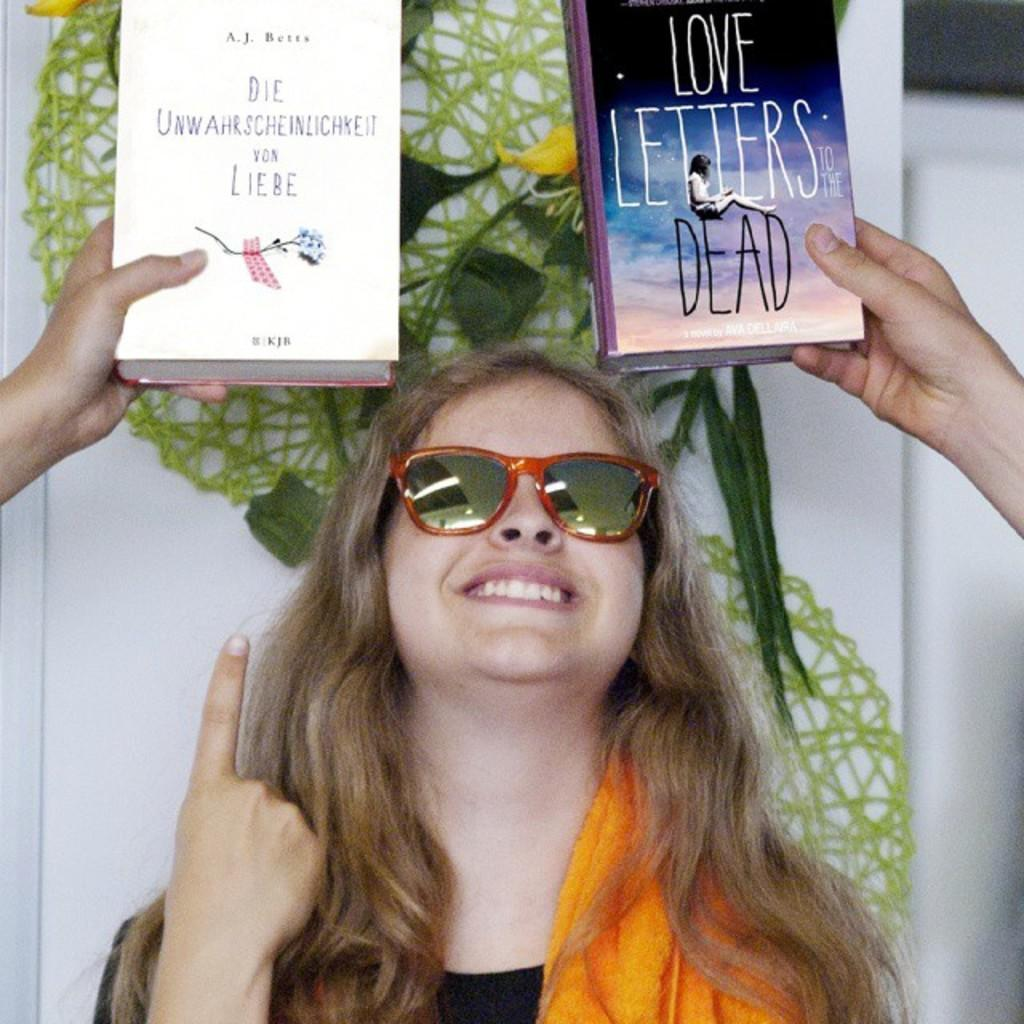Who is the main subject in the image? There is a lady in the center of the image. What is the lady doing in the image? The lady is smiling. What is the lady wearing in the image? The lady is wearing a dress and goggles. What can be seen in the background of the image? There is a wall, decor, hands, and books visible in the background. What role does the actor play in the image? There is no actor present in the image; it features a lady wearing a dress and goggles. How does the lady's memory affect the image? The image does not depict any memories or their effects; it is a static representation of the lady and her surroundings. 